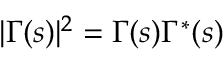<formula> <loc_0><loc_0><loc_500><loc_500>| \Gamma ( s ) | ^ { 2 } = \Gamma ( s ) \Gamma ^ { * } ( s )</formula> 